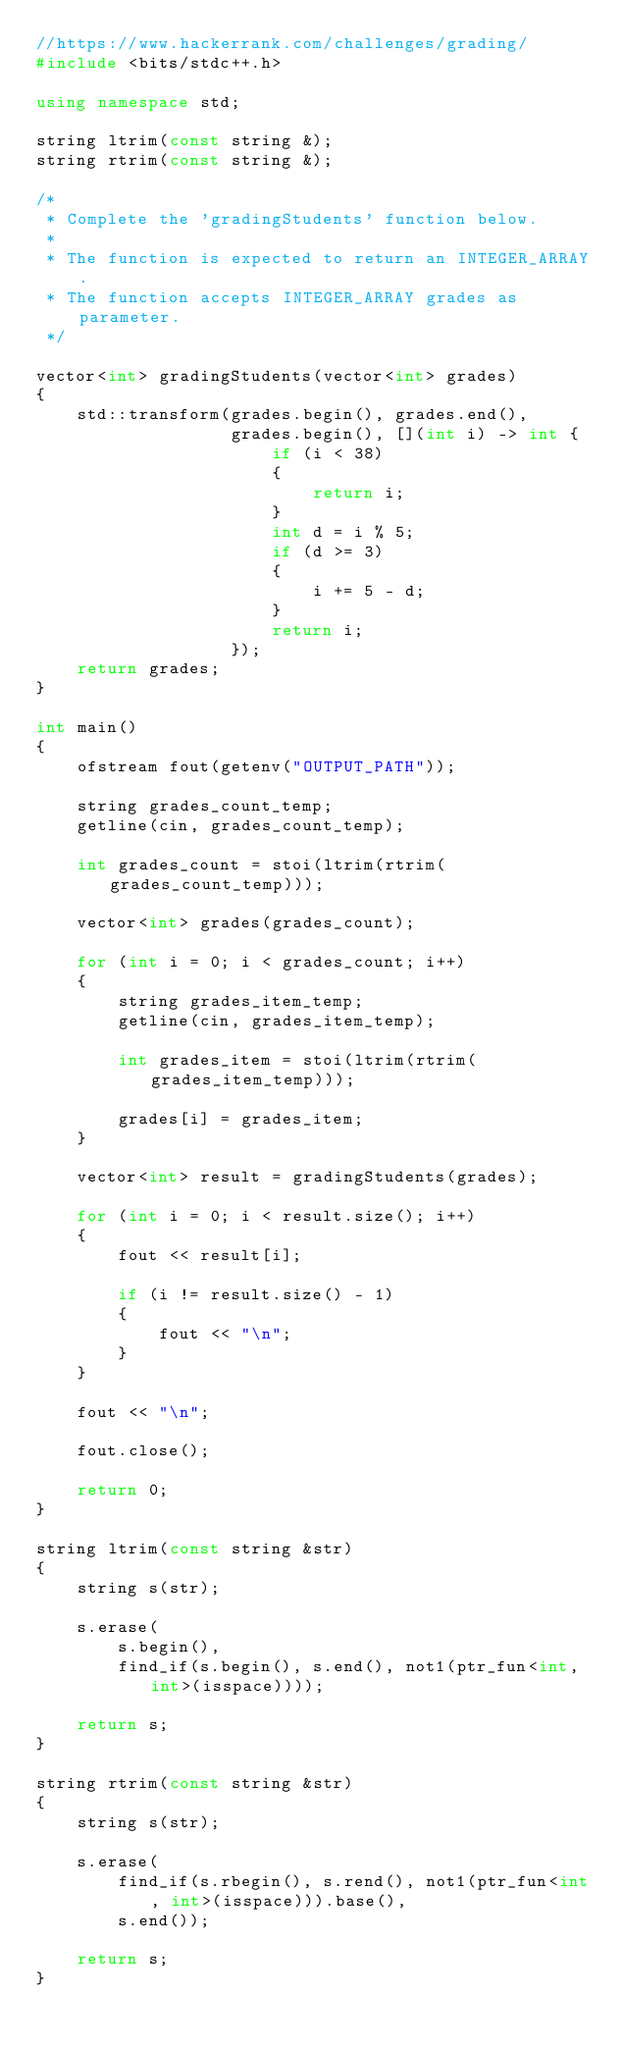Convert code to text. <code><loc_0><loc_0><loc_500><loc_500><_C++_>//https://www.hackerrank.com/challenges/grading/
#include <bits/stdc++.h>

using namespace std;

string ltrim(const string &);
string rtrim(const string &);

/*
 * Complete the 'gradingStudents' function below.
 *
 * The function is expected to return an INTEGER_ARRAY.
 * The function accepts INTEGER_ARRAY grades as parameter.
 */

vector<int> gradingStudents(vector<int> grades)
{
    std::transform(grades.begin(), grades.end(),
                   grades.begin(), [](int i) -> int {
                       if (i < 38)
                       {
                           return i;
                       }
                       int d = i % 5;
                       if (d >= 3)
                       {
                           i += 5 - d;
                       }
                       return i;
                   });
    return grades;
}

int main()
{
    ofstream fout(getenv("OUTPUT_PATH"));

    string grades_count_temp;
    getline(cin, grades_count_temp);

    int grades_count = stoi(ltrim(rtrim(grades_count_temp)));

    vector<int> grades(grades_count);

    for (int i = 0; i < grades_count; i++)
    {
        string grades_item_temp;
        getline(cin, grades_item_temp);

        int grades_item = stoi(ltrim(rtrim(grades_item_temp)));

        grades[i] = grades_item;
    }

    vector<int> result = gradingStudents(grades);

    for (int i = 0; i < result.size(); i++)
    {
        fout << result[i];

        if (i != result.size() - 1)
        {
            fout << "\n";
        }
    }

    fout << "\n";

    fout.close();

    return 0;
}

string ltrim(const string &str)
{
    string s(str);

    s.erase(
        s.begin(),
        find_if(s.begin(), s.end(), not1(ptr_fun<int, int>(isspace))));

    return s;
}

string rtrim(const string &str)
{
    string s(str);

    s.erase(
        find_if(s.rbegin(), s.rend(), not1(ptr_fun<int, int>(isspace))).base(),
        s.end());

    return s;
}</code> 